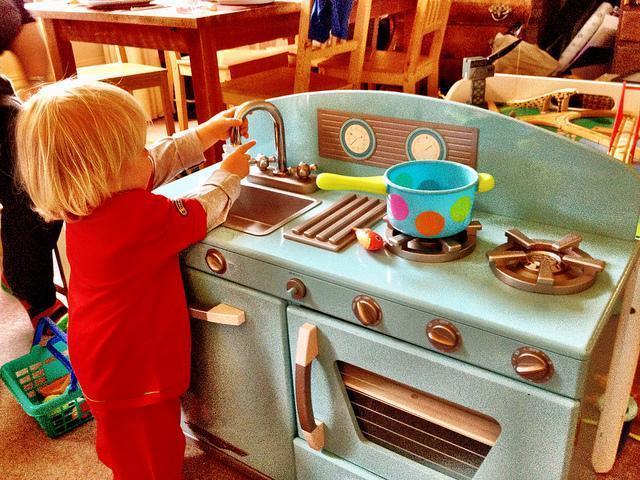How many chairs are there?
Give a very brief answer. 4. How many people are there?
Give a very brief answer. 2. How many cats are there?
Give a very brief answer. 0. 